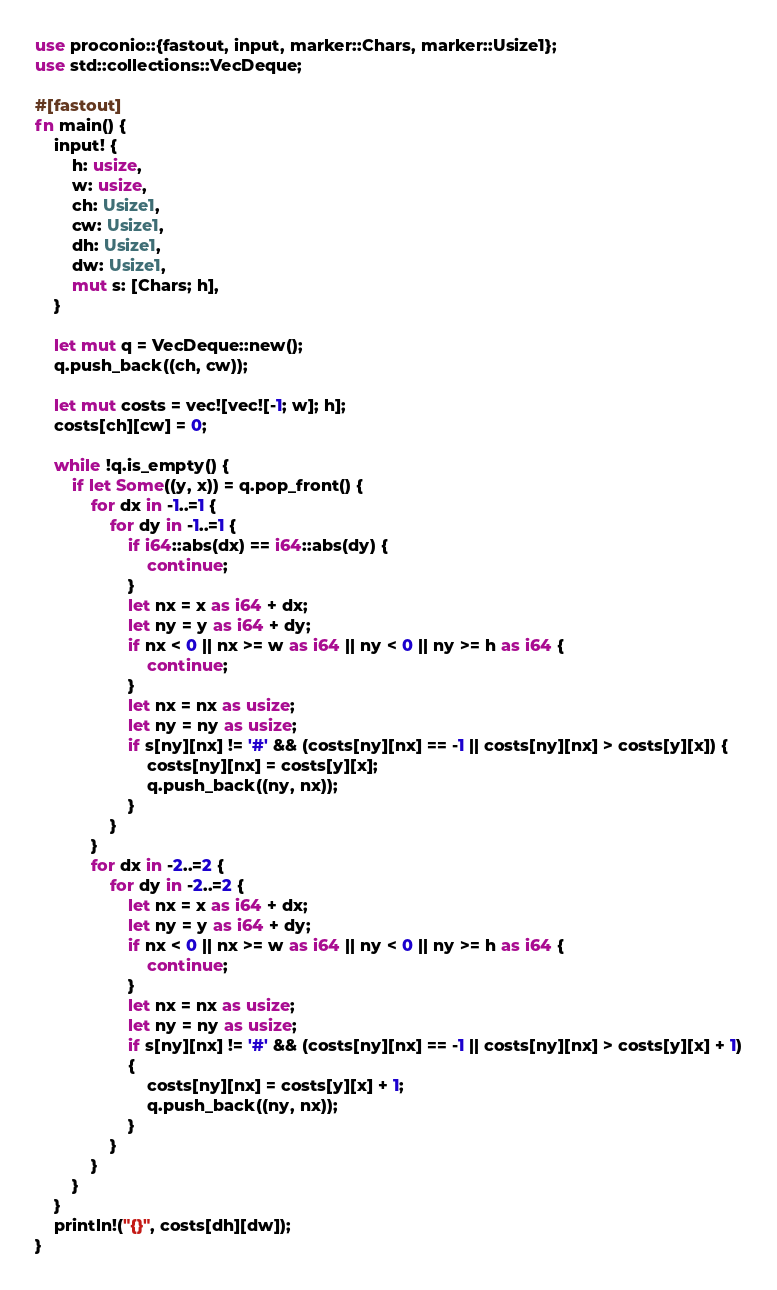Convert code to text. <code><loc_0><loc_0><loc_500><loc_500><_Rust_>use proconio::{fastout, input, marker::Chars, marker::Usize1};
use std::collections::VecDeque;

#[fastout]
fn main() {
    input! {
        h: usize,
        w: usize,
        ch: Usize1,
        cw: Usize1,
        dh: Usize1,
        dw: Usize1,
        mut s: [Chars; h],
    }

    let mut q = VecDeque::new();
    q.push_back((ch, cw));

    let mut costs = vec![vec![-1; w]; h];
    costs[ch][cw] = 0;

    while !q.is_empty() {
        if let Some((y, x)) = q.pop_front() {
            for dx in -1..=1 {
                for dy in -1..=1 {
                    if i64::abs(dx) == i64::abs(dy) {
                        continue;
                    }
                    let nx = x as i64 + dx;
                    let ny = y as i64 + dy;
                    if nx < 0 || nx >= w as i64 || ny < 0 || ny >= h as i64 {
                        continue;
                    }
                    let nx = nx as usize;
                    let ny = ny as usize;
                    if s[ny][nx] != '#' && (costs[ny][nx] == -1 || costs[ny][nx] > costs[y][x]) {
                        costs[ny][nx] = costs[y][x];
                        q.push_back((ny, nx));
                    }
                }
            }
            for dx in -2..=2 {
                for dy in -2..=2 {
                    let nx = x as i64 + dx;
                    let ny = y as i64 + dy;
                    if nx < 0 || nx >= w as i64 || ny < 0 || ny >= h as i64 {
                        continue;
                    }
                    let nx = nx as usize;
                    let ny = ny as usize;
                    if s[ny][nx] != '#' && (costs[ny][nx] == -1 || costs[ny][nx] > costs[y][x] + 1)
                    {
                        costs[ny][nx] = costs[y][x] + 1;
                        q.push_back((ny, nx));
                    }
                }
            }
        }
    }
    println!("{}", costs[dh][dw]);
}
</code> 